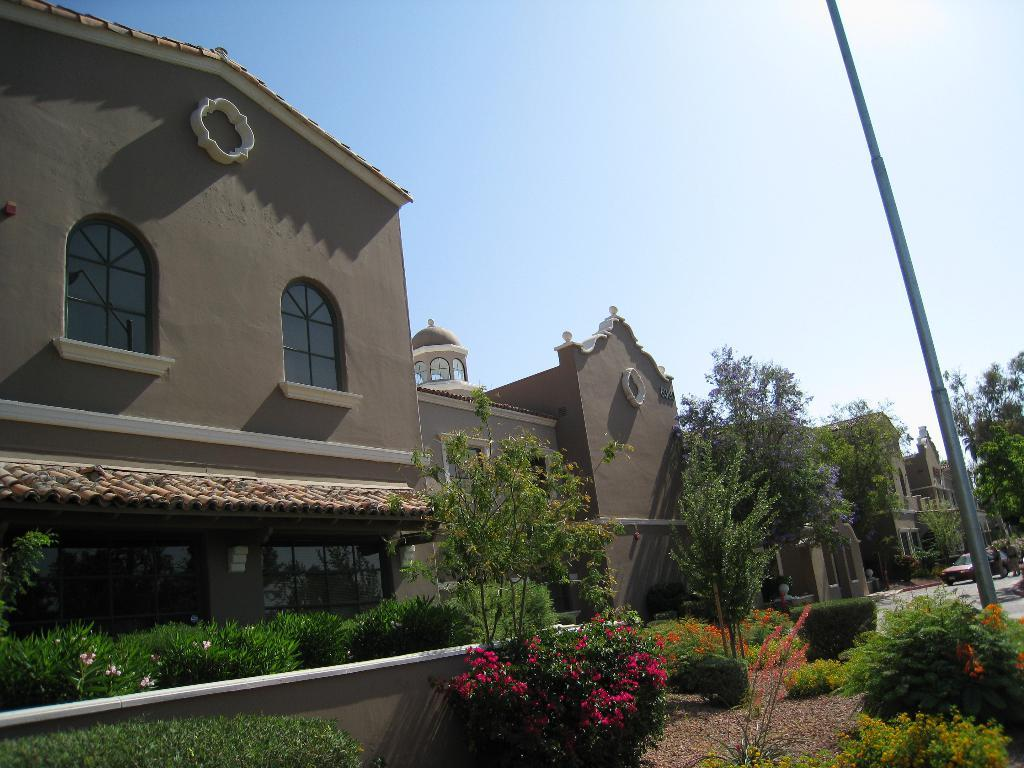What type of structures can be seen in the image? There are buildings in the image. What is located in front of the buildings? There are trees and plants in front of the buildings. Can you describe any other objects in the image? There is a pole in the image. What can be seen in the background of the image? The sky is visible in the background of the image. How many beads are hanging from the boundary in the image? There is no boundary or beads present in the image. 